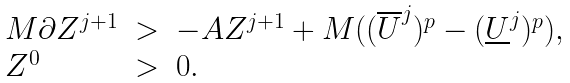Convert formula to latex. <formula><loc_0><loc_0><loc_500><loc_500>\begin{array} { l c l } M \partial Z ^ { j + 1 } & > & - A Z ^ { j + 1 } + M ( ( \overline { U } ^ { j } ) ^ { p } - ( \underline { U } ^ { j } ) ^ { p } ) , \\ Z ^ { 0 } & > & 0 . \end{array}</formula> 